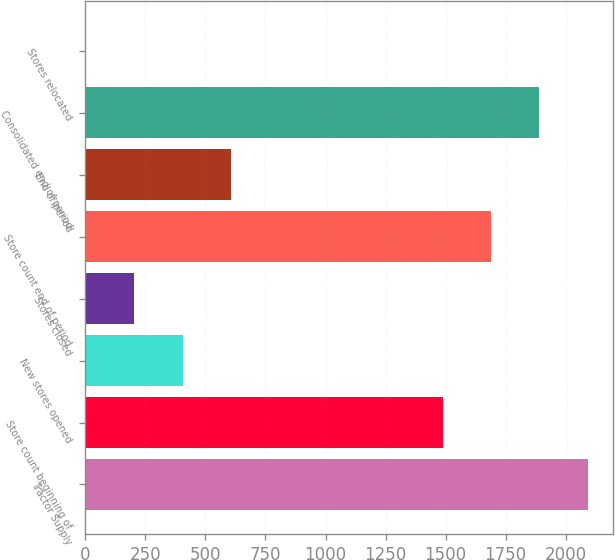Convert chart to OTSL. <chart><loc_0><loc_0><loc_500><loc_500><bar_chart><fcel>Tractor Supply<fcel>Store count beginning of<fcel>New stores opened<fcel>Stores closed<fcel>Store count end of period<fcel>End of period<fcel>Consolidated end of period<fcel>Stores relocated<nl><fcel>2091.9<fcel>1488<fcel>405.6<fcel>204.3<fcel>1689.3<fcel>606.9<fcel>1890.6<fcel>3<nl></chart> 